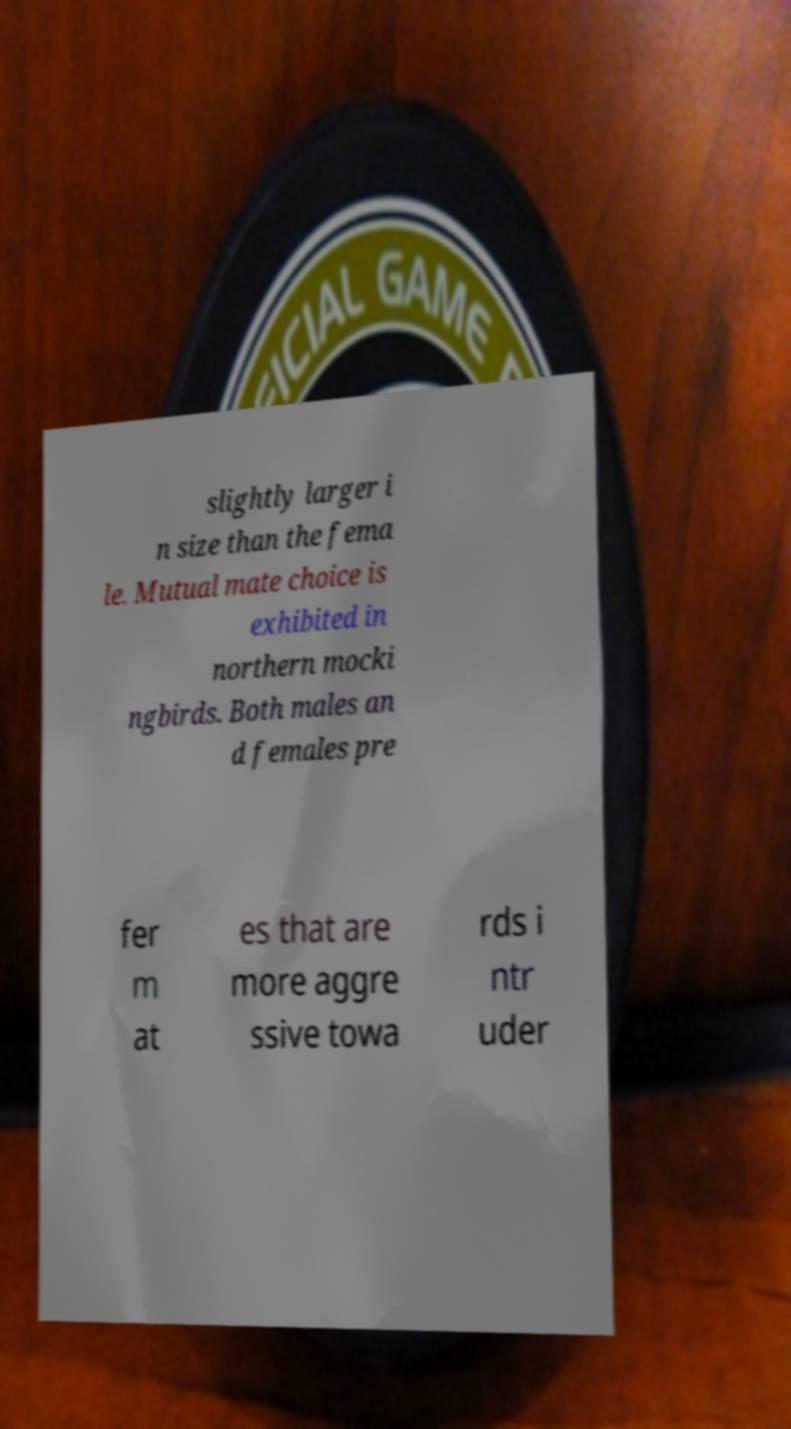Could you assist in decoding the text presented in this image and type it out clearly? slightly larger i n size than the fema le. Mutual mate choice is exhibited in northern mocki ngbirds. Both males an d females pre fer m at es that are more aggre ssive towa rds i ntr uder 